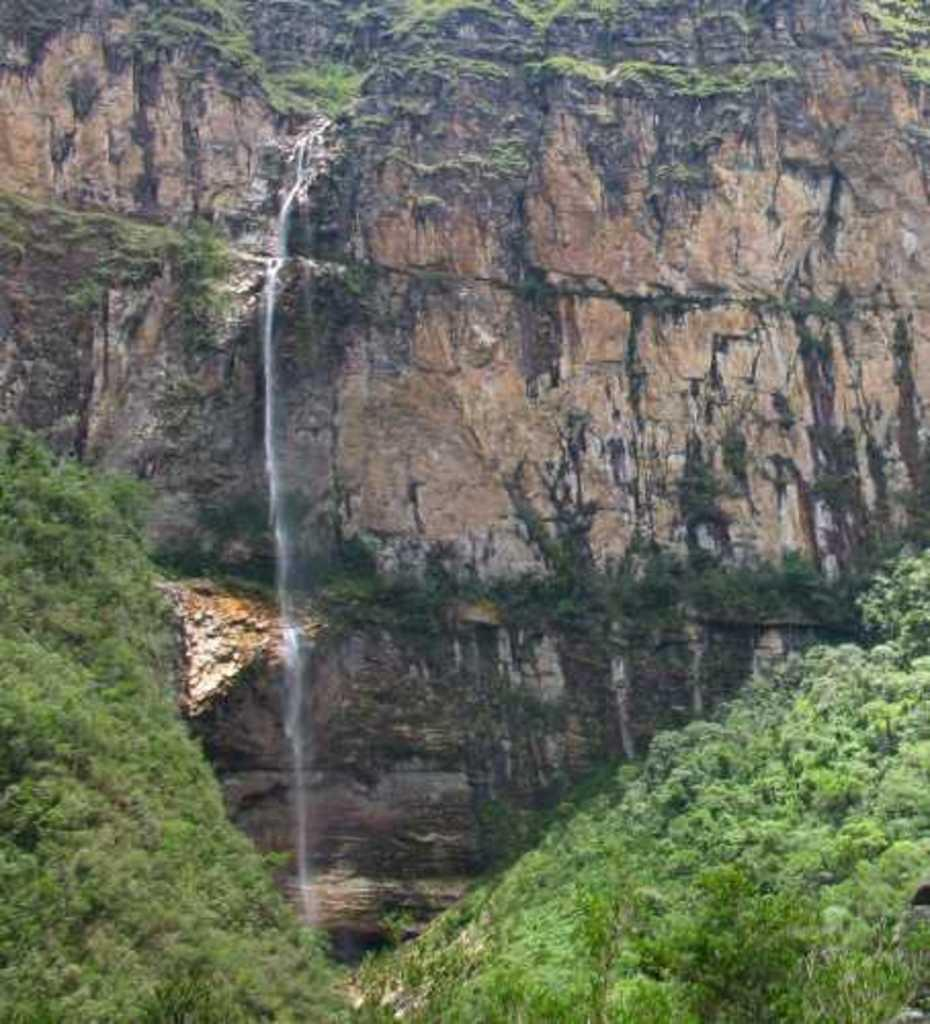What type of vegetation is present in the image? There are many trees in the image. What geographical feature can be seen in the image? There is a hill in the image. What is happening on the hill in the image? Water is falling from the hill in the image. Can you see a snail climbing up the hill in the image? There is no snail present in the image. What is the neck of the hill like in the image? The hill does not have a neck; it is a geographical feature without a neck. 